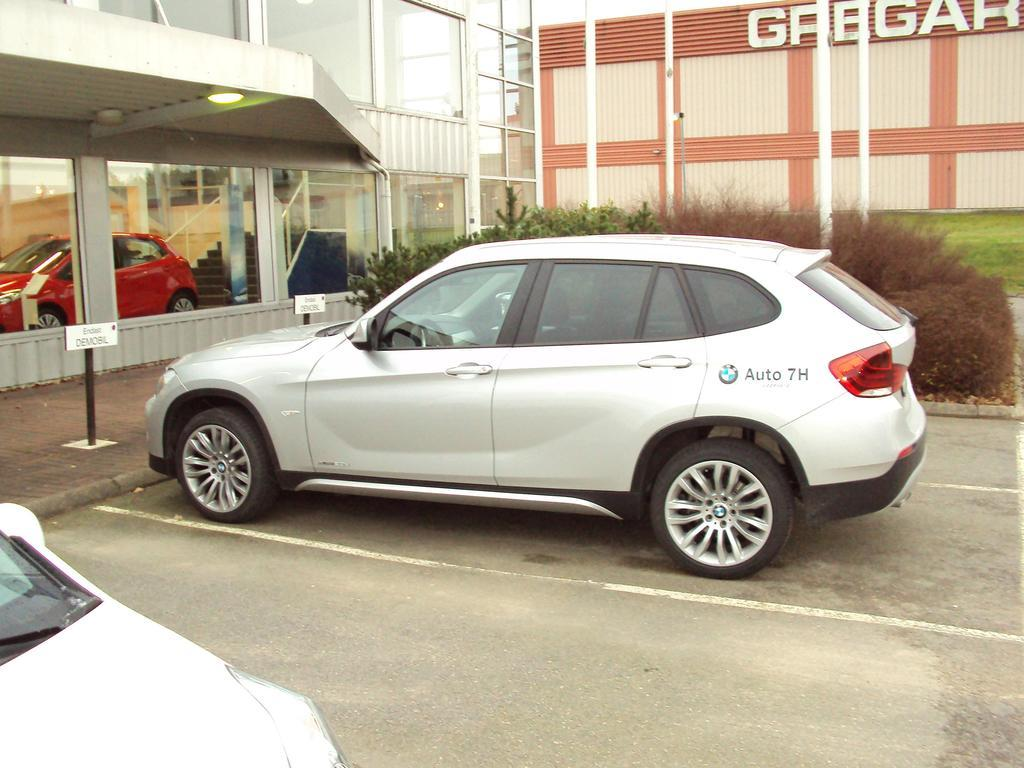What can be seen on the ground in the image? There are cars parked on the ground in the image. What is at the bottom of the image? There is a road at the bottom of the image. What structures are visible in the front of the image? There are buildings visible in the front of the image. What type of vegetation is present in the image? There are plants and green grass in the image. What grade of coil is used in the process depicted in the image? There is no process or coil present in the image; it features cars, a road, buildings, plants, and green grass. 